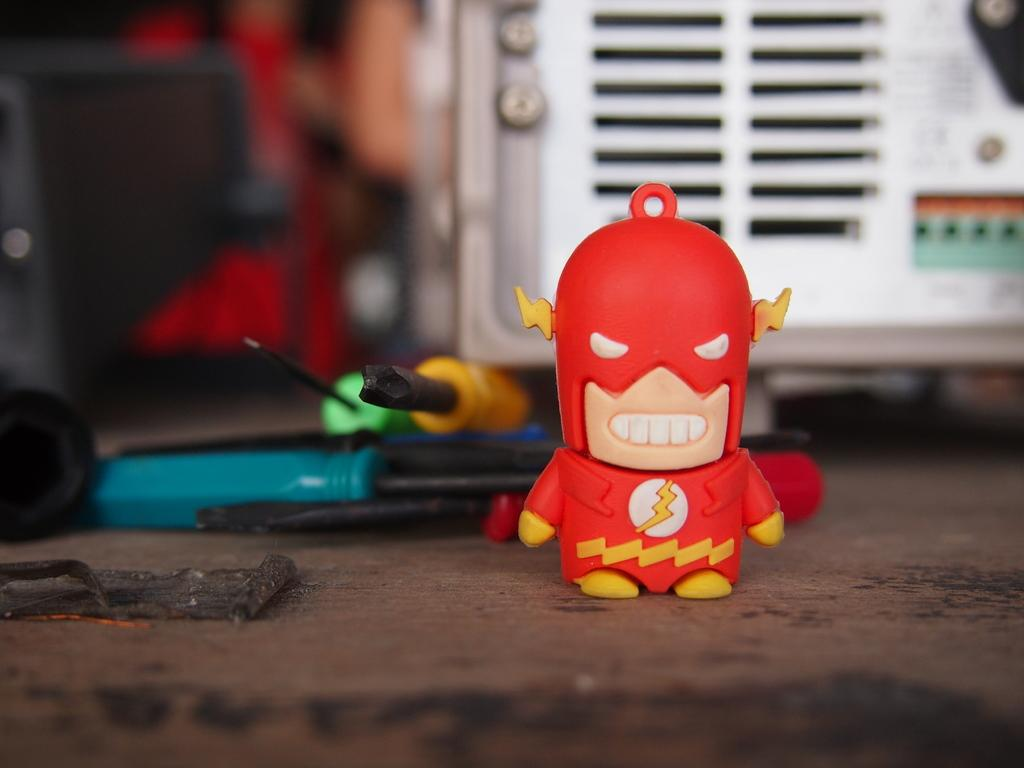What object can be seen in the image that is typically used for play? There is a toy in the image that is typically used for play. What tools are visible in the image? There are screwdrivers in the image. Where are the toy and screwdrivers located in the image? The toy and screwdrivers are on a platform in the image. How would you describe the background of the image? The background of the image is blurry. Can you see any representatives from the government in the image? There are no representatives from the government present in the image. What type of seashore can be seen in the image? There is no seashore present in the image; it features a toy and screwdrivers on a platform. Is there a rail visible in the image? There is no rail present in the image. 